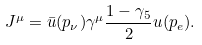<formula> <loc_0><loc_0><loc_500><loc_500>J ^ { \mu } = \bar { u } ( p _ { \nu } ) \gamma ^ { \mu } \frac { 1 - \gamma _ { 5 } } { 2 } u ( p _ { e } ) .</formula> 